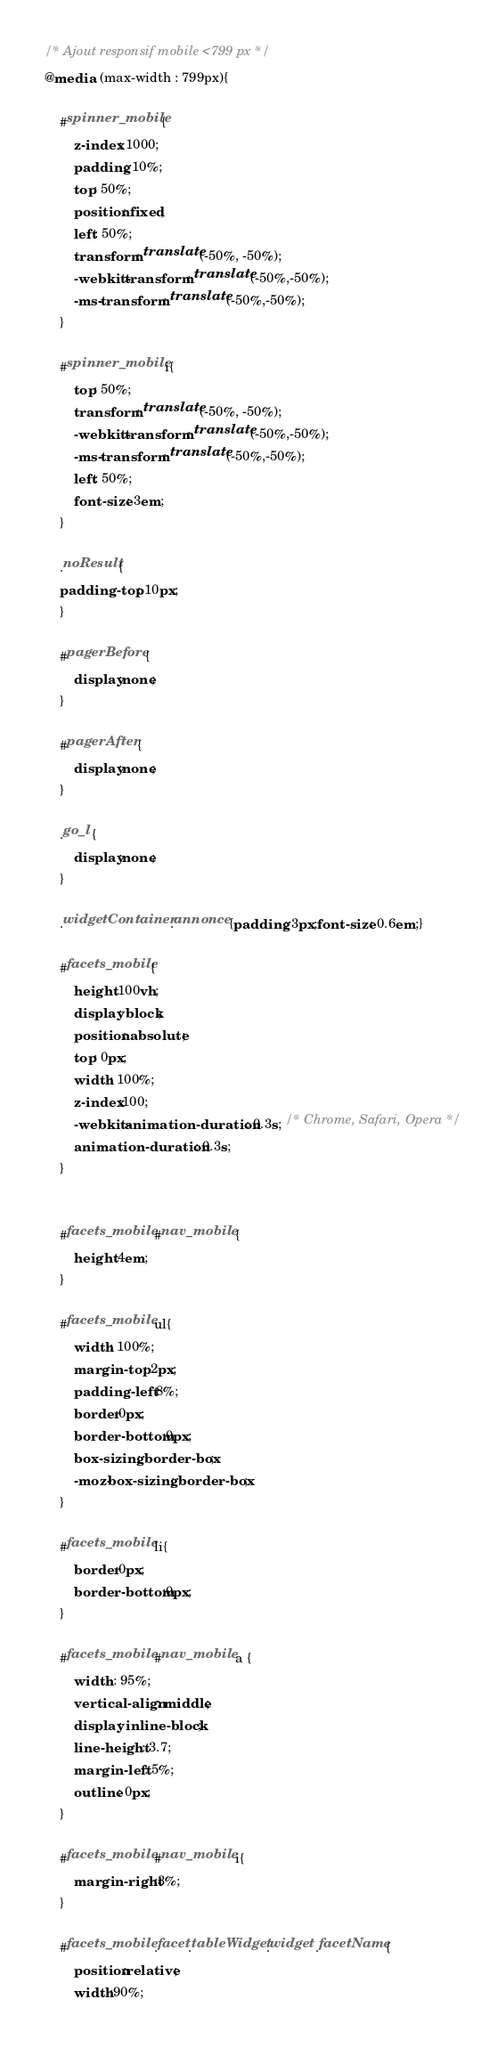Convert code to text. <code><loc_0><loc_0><loc_500><loc_500><_CSS_>/* Ajout responsif mobile <799 px */
@media  (max-width : 799px){

	#spinner_mobile{
		z-index: 1000;
		padding: 10%;
		top: 50%;
		position: fixed;
		left: 50%;
		transform: translate(-50%, -50%);
		-webkit-transform: translate(-50%,-50%);
		-ms-transform: translate(-50%,-50%);
	}
	
	#spinner_mobile i{
		top: 50%;
		transform: translate(-50%, -50%);
		-webkit-transform: translate(-50%,-50%);
		-ms-transform: translate(-50%,-50%);
		left: 50%;
		font-size: 3em;
	}
	
	.noResult{
	padding-top : 10px;
	}
	
	#pagerBefore {
		display:none;
	}
	
	#pagerAfter {
		display:none;
	}
	
	.go_l {
		display:none;
	}
	
	.widgetContainer .annonce {padding: 3px;font-size: 0.6em;}
	
	#facets_mobile{
	    height:100vh;
		display: block;
		position: absolute;
	    top: 0px;
	    width: 100%;
	 	z-index:100;
	    -webkit-animation-duration: 0.3s; /* Chrome, Safari, Opera */
	    animation-duration: 0.3s;
	}
	
	
	#facets_mobile #nav_mobile {
	    height:4em;
	}
	
	#facets_mobile ul{
		width: 100%;
		margin-top: 2px;
		padding-left: 8%;
		border:0px;
		border-bottom:0px;
		box-sizing: border-box;
		-moz-box-sizing: border-box;
	}
	
	#facets_mobile li{
		border:0px;
		border-bottom:0px;
	}
	
	#facets_mobile #nav_mobile a {
		width : 95%;
		vertical-align: middle;
		display: inline-block;
		line-height: 3.7;
		margin-left: 5%;
		outline: 0px;
	}
	
	#facets_mobile #nav_mobile i{
		margin-right:3%;
	}
	
	#facets_mobile .facet.tableWidget.widget .facetName{
		position:relative;
		width:90%;</code> 